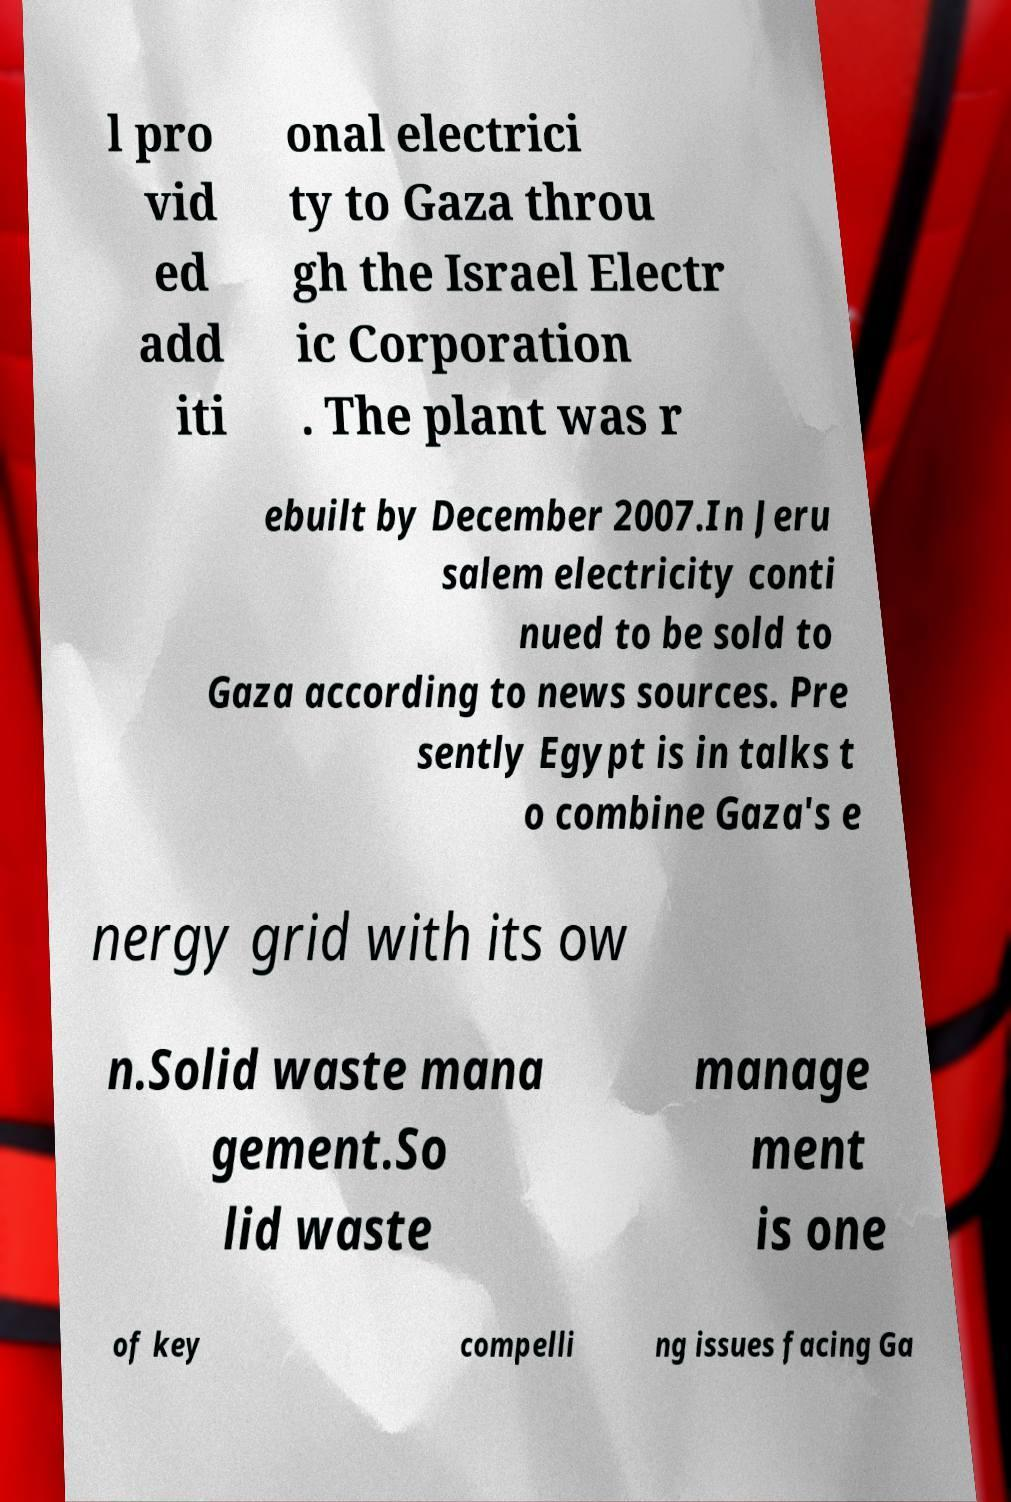Please read and relay the text visible in this image. What does it say? l pro vid ed add iti onal electrici ty to Gaza throu gh the Israel Electr ic Corporation . The plant was r ebuilt by December 2007.In Jeru salem electricity conti nued to be sold to Gaza according to news sources. Pre sently Egypt is in talks t o combine Gaza's e nergy grid with its ow n.Solid waste mana gement.So lid waste manage ment is one of key compelli ng issues facing Ga 